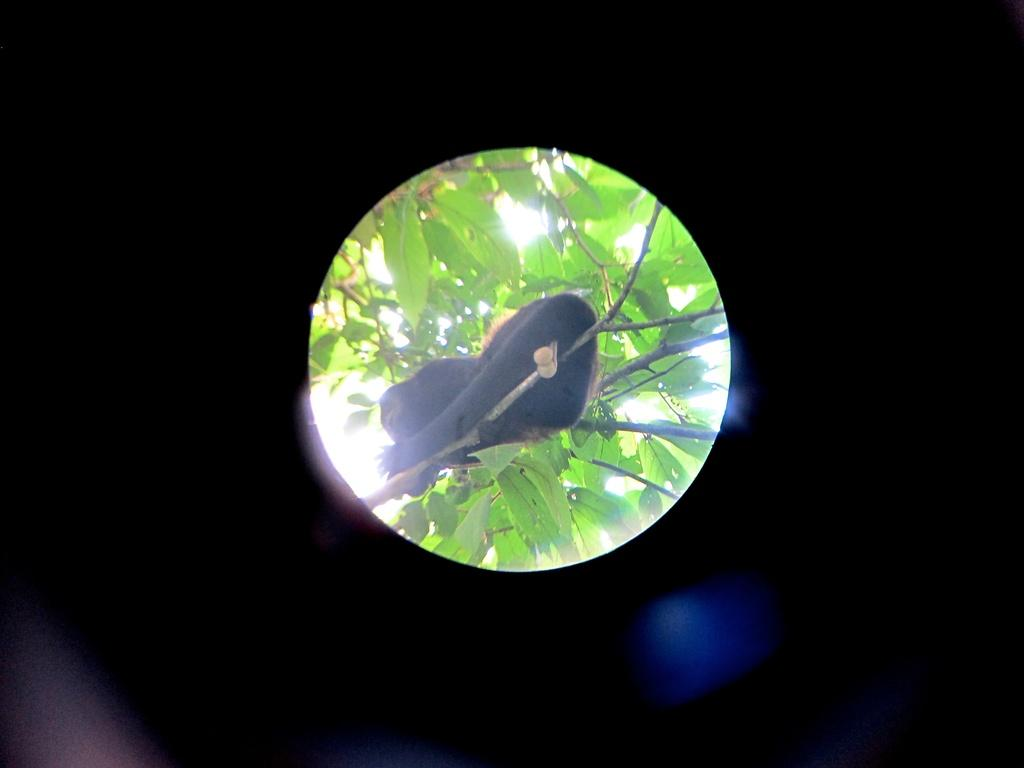What animal is present in the image? There is a monkey in the image. Where is the monkey located? The monkey is sitting on a branch of a tree. What can be seen in the background of the image? The sky is visible in the background of the image. What color is the crayon that the monkey is holding in the image? There is no crayon present in the image; the monkey is sitting on a branch of a tree. 